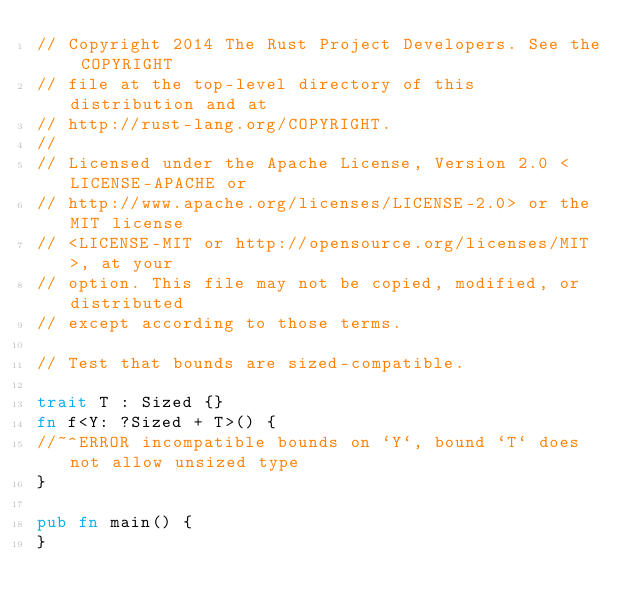<code> <loc_0><loc_0><loc_500><loc_500><_Rust_>// Copyright 2014 The Rust Project Developers. See the COPYRIGHT
// file at the top-level directory of this distribution and at
// http://rust-lang.org/COPYRIGHT.
//
// Licensed under the Apache License, Version 2.0 <LICENSE-APACHE or
// http://www.apache.org/licenses/LICENSE-2.0> or the MIT license
// <LICENSE-MIT or http://opensource.org/licenses/MIT>, at your
// option. This file may not be copied, modified, or distributed
// except according to those terms.

// Test that bounds are sized-compatible.

trait T : Sized {}
fn f<Y: ?Sized + T>() {
//~^ERROR incompatible bounds on `Y`, bound `T` does not allow unsized type
}

pub fn main() {
}
</code> 